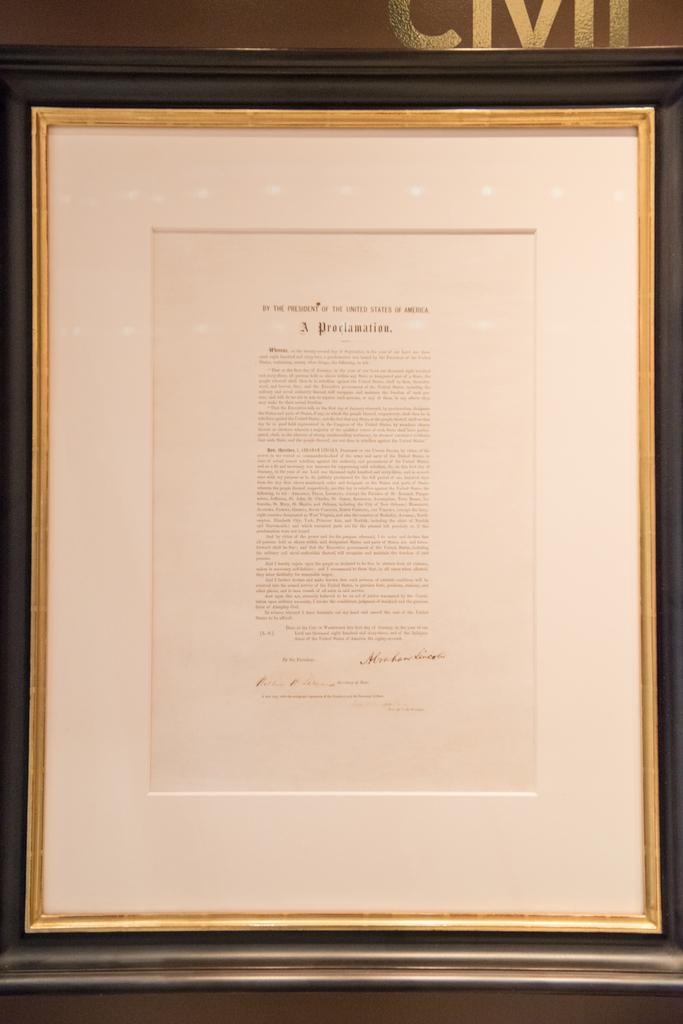<image>
Summarize the visual content of the image. A framed document that says A Proclamation on it. 